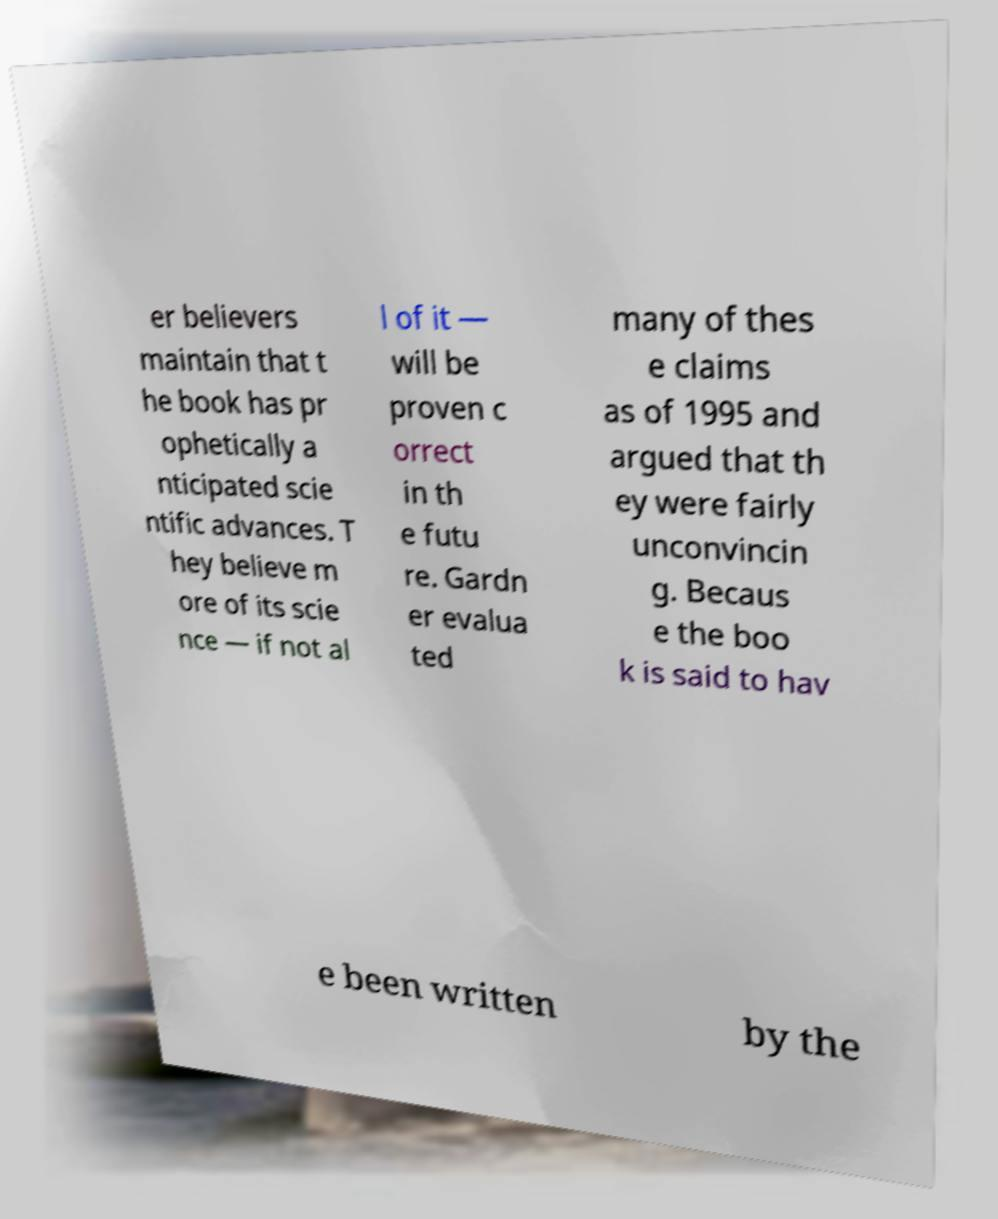There's text embedded in this image that I need extracted. Can you transcribe it verbatim? er believers maintain that t he book has pr ophetically a nticipated scie ntific advances. T hey believe m ore of its scie nce — if not al l of it — will be proven c orrect in th e futu re. Gardn er evalua ted many of thes e claims as of 1995 and argued that th ey were fairly unconvincin g. Becaus e the boo k is said to hav e been written by the 